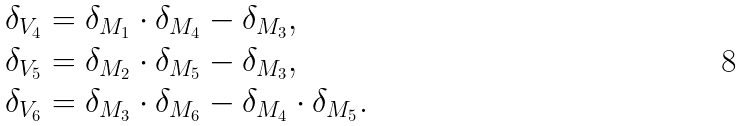Convert formula to latex. <formula><loc_0><loc_0><loc_500><loc_500>\delta _ { V _ { 4 } } & = \delta _ { M _ { 1 } } \cdot \delta _ { M _ { 4 } } - \delta _ { M _ { 3 } } , \\ \delta _ { V _ { 5 } } & = \delta _ { M _ { 2 } } \cdot \delta _ { M _ { 5 } } - \delta _ { M _ { 3 } } , \\ \delta _ { V _ { 6 } } & = \delta _ { M _ { 3 } } \cdot \delta _ { M _ { 6 } } - \delta _ { M _ { 4 } } \cdot \delta _ { M _ { 5 } } .</formula> 